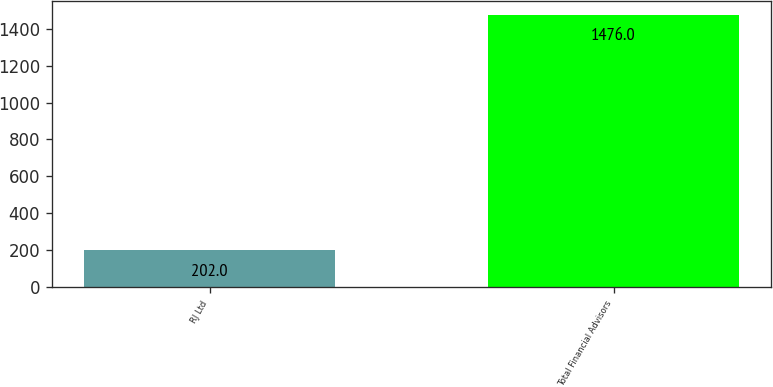Convert chart. <chart><loc_0><loc_0><loc_500><loc_500><bar_chart><fcel>RJ Ltd<fcel>Total Financial Advisors<nl><fcel>202<fcel>1476<nl></chart> 